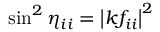Convert formula to latex. <formula><loc_0><loc_0><loc_500><loc_500>\sin ^ { 2 } \eta _ { i i } = \left | k f _ { i i } \right | ^ { 2 }</formula> 